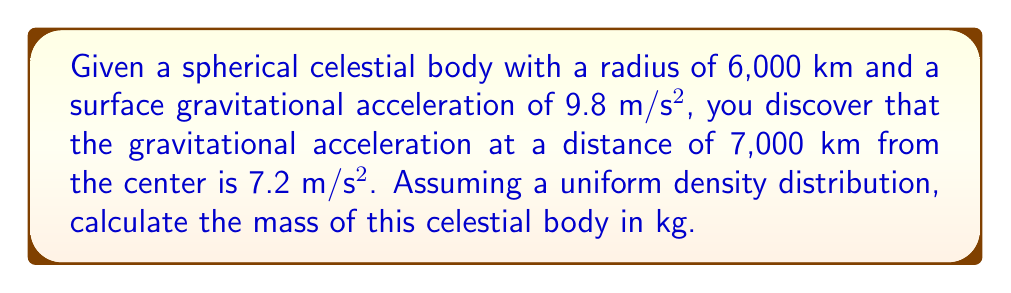Solve this math problem. Let's approach this step-by-step:

1) First, recall Newton's law of universal gravitation:

   $$F = G\frac{Mm}{r^2}$$

   where $G$ is the gravitational constant, $M$ is the mass of the celestial body, $m$ is the mass of the test object, and $r$ is the distance from the center of the body.

2) The gravitational acceleration $g$ is given by $F/m$:

   $$g = G\frac{M}{r^2}$$

3) We can use this equation at the surface:

   $$9.8 = G\frac{M}{(6000000)^2}$$

4) And at 7,000 km from the center:

   $$7.2 = G\frac{M}{(7000000)^2}$$

5) Dividing these equations:

   $$\frac{9.8}{7.2} = \frac{(7000000)^2}{(6000000)^2}$$

6) This confirms that the acceleration follows the inverse square law, supporting the uniform density assumption.

7) Now, let's solve for $M$ using the surface equation:

   $$M = \frac{9.8 \times (6000000)^2}{G}$$

8) The value of $G$ is approximately $6.674 \times 10^{-11}$ m³/(kg·s²).

9) Plugging in the values:

   $$M = \frac{9.8 \times (6000000)^2}{6.674 \times 10^{-11}} = 5.27 \times 10^{24} \text{ kg}$$
Answer: $5.27 \times 10^{24}$ kg 